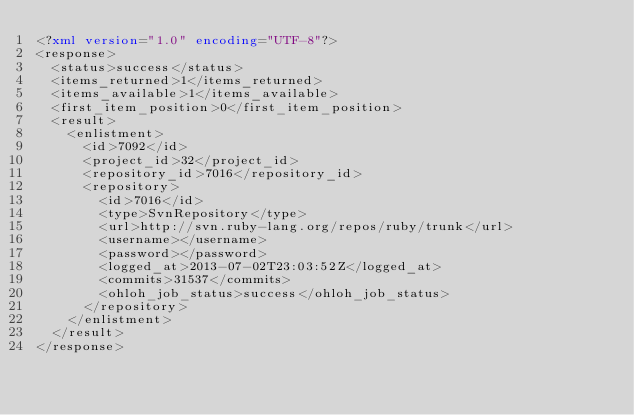Convert code to text. <code><loc_0><loc_0><loc_500><loc_500><_XML_><?xml version="1.0" encoding="UTF-8"?>
<response>
  <status>success</status>
  <items_returned>1</items_returned>
  <items_available>1</items_available>
  <first_item_position>0</first_item_position>
  <result>
    <enlistment>
      <id>7092</id>
      <project_id>32</project_id>
      <repository_id>7016</repository_id>
      <repository>
        <id>7016</id>
        <type>SvnRepository</type>
        <url>http://svn.ruby-lang.org/repos/ruby/trunk</url>
        <username></username>
        <password></password>
        <logged_at>2013-07-02T23:03:52Z</logged_at>
        <commits>31537</commits>
        <ohloh_job_status>success</ohloh_job_status>
      </repository>
    </enlistment>
  </result>
</response>
</code> 